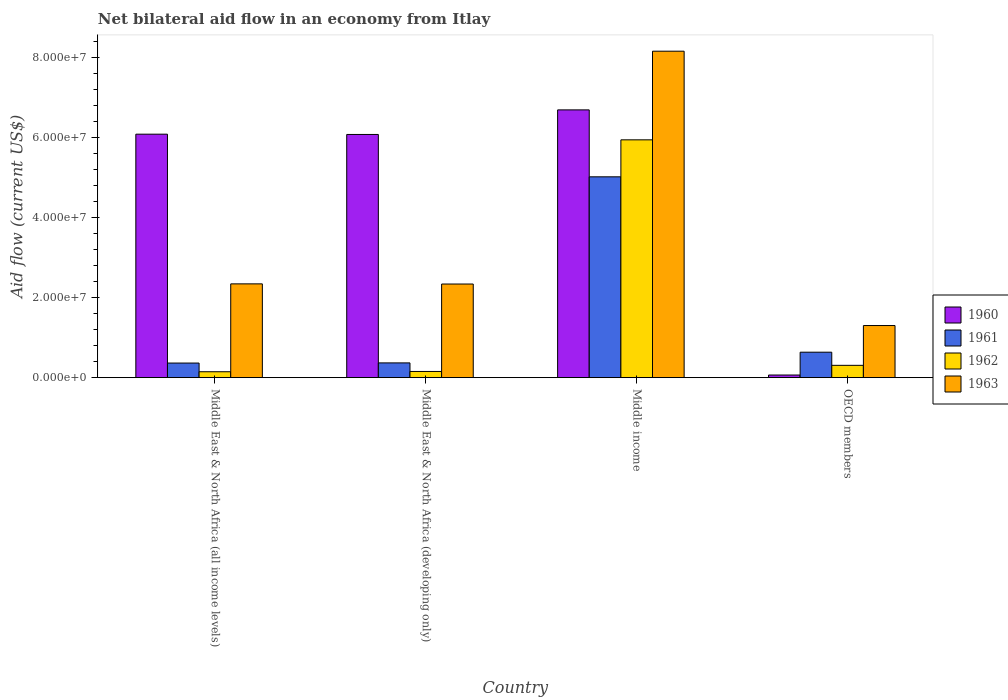How many different coloured bars are there?
Ensure brevity in your answer.  4. Are the number of bars per tick equal to the number of legend labels?
Give a very brief answer. Yes. How many bars are there on the 2nd tick from the left?
Give a very brief answer. 4. How many bars are there on the 2nd tick from the right?
Provide a short and direct response. 4. What is the label of the 1st group of bars from the left?
Give a very brief answer. Middle East & North Africa (all income levels). In how many cases, is the number of bars for a given country not equal to the number of legend labels?
Your answer should be compact. 0. What is the net bilateral aid flow in 1961 in Middle income?
Your response must be concise. 5.02e+07. Across all countries, what is the maximum net bilateral aid flow in 1960?
Your response must be concise. 6.69e+07. Across all countries, what is the minimum net bilateral aid flow in 1962?
Offer a very short reply. 1.48e+06. In which country was the net bilateral aid flow in 1961 maximum?
Offer a terse response. Middle income. In which country was the net bilateral aid flow in 1960 minimum?
Make the answer very short. OECD members. What is the total net bilateral aid flow in 1963 in the graph?
Give a very brief answer. 1.41e+08. What is the difference between the net bilateral aid flow in 1960 in Middle income and that in OECD members?
Make the answer very short. 6.62e+07. What is the difference between the net bilateral aid flow in 1962 in OECD members and the net bilateral aid flow in 1963 in Middle East & North Africa (all income levels)?
Your answer should be very brief. -2.04e+07. What is the average net bilateral aid flow in 1960 per country?
Your answer should be compact. 4.73e+07. What is the difference between the net bilateral aid flow of/in 1963 and net bilateral aid flow of/in 1962 in Middle income?
Ensure brevity in your answer.  2.21e+07. What is the ratio of the net bilateral aid flow in 1963 in Middle East & North Africa (all income levels) to that in OECD members?
Ensure brevity in your answer.  1.8. Is the difference between the net bilateral aid flow in 1963 in Middle East & North Africa (all income levels) and OECD members greater than the difference between the net bilateral aid flow in 1962 in Middle East & North Africa (all income levels) and OECD members?
Offer a terse response. Yes. What is the difference between the highest and the second highest net bilateral aid flow in 1963?
Make the answer very short. 5.82e+07. What is the difference between the highest and the lowest net bilateral aid flow in 1961?
Your response must be concise. 4.65e+07. Is it the case that in every country, the sum of the net bilateral aid flow in 1961 and net bilateral aid flow in 1963 is greater than the sum of net bilateral aid flow in 1962 and net bilateral aid flow in 1960?
Provide a short and direct response. Yes. What does the 2nd bar from the right in Middle East & North Africa (all income levels) represents?
Provide a succinct answer. 1962. Is it the case that in every country, the sum of the net bilateral aid flow in 1962 and net bilateral aid flow in 1960 is greater than the net bilateral aid flow in 1961?
Provide a succinct answer. No. How many bars are there?
Your answer should be very brief. 16. How many countries are there in the graph?
Ensure brevity in your answer.  4. What is the difference between two consecutive major ticks on the Y-axis?
Provide a succinct answer. 2.00e+07. Are the values on the major ticks of Y-axis written in scientific E-notation?
Your answer should be compact. Yes. Where does the legend appear in the graph?
Make the answer very short. Center right. What is the title of the graph?
Your answer should be very brief. Net bilateral aid flow in an economy from Itlay. What is the Aid flow (current US$) of 1960 in Middle East & North Africa (all income levels)?
Your answer should be very brief. 6.08e+07. What is the Aid flow (current US$) of 1961 in Middle East & North Africa (all income levels)?
Ensure brevity in your answer.  3.65e+06. What is the Aid flow (current US$) in 1962 in Middle East & North Africa (all income levels)?
Ensure brevity in your answer.  1.48e+06. What is the Aid flow (current US$) in 1963 in Middle East & North Africa (all income levels)?
Your response must be concise. 2.34e+07. What is the Aid flow (current US$) of 1960 in Middle East & North Africa (developing only)?
Make the answer very short. 6.08e+07. What is the Aid flow (current US$) of 1961 in Middle East & North Africa (developing only)?
Ensure brevity in your answer.  3.69e+06. What is the Aid flow (current US$) in 1962 in Middle East & North Africa (developing only)?
Offer a very short reply. 1.55e+06. What is the Aid flow (current US$) of 1963 in Middle East & North Africa (developing only)?
Make the answer very short. 2.34e+07. What is the Aid flow (current US$) in 1960 in Middle income?
Provide a short and direct response. 6.69e+07. What is the Aid flow (current US$) of 1961 in Middle income?
Your response must be concise. 5.02e+07. What is the Aid flow (current US$) in 1962 in Middle income?
Keep it short and to the point. 5.94e+07. What is the Aid flow (current US$) of 1963 in Middle income?
Make the answer very short. 8.16e+07. What is the Aid flow (current US$) of 1960 in OECD members?
Your answer should be compact. 6.60e+05. What is the Aid flow (current US$) in 1961 in OECD members?
Offer a very short reply. 6.36e+06. What is the Aid flow (current US$) of 1962 in OECD members?
Offer a terse response. 3.08e+06. What is the Aid flow (current US$) of 1963 in OECD members?
Offer a terse response. 1.30e+07. Across all countries, what is the maximum Aid flow (current US$) of 1960?
Your response must be concise. 6.69e+07. Across all countries, what is the maximum Aid flow (current US$) of 1961?
Keep it short and to the point. 5.02e+07. Across all countries, what is the maximum Aid flow (current US$) of 1962?
Keep it short and to the point. 5.94e+07. Across all countries, what is the maximum Aid flow (current US$) of 1963?
Keep it short and to the point. 8.16e+07. Across all countries, what is the minimum Aid flow (current US$) in 1961?
Offer a terse response. 3.65e+06. Across all countries, what is the minimum Aid flow (current US$) in 1962?
Make the answer very short. 1.48e+06. Across all countries, what is the minimum Aid flow (current US$) of 1963?
Your answer should be compact. 1.30e+07. What is the total Aid flow (current US$) in 1960 in the graph?
Your answer should be very brief. 1.89e+08. What is the total Aid flow (current US$) of 1961 in the graph?
Your answer should be very brief. 6.39e+07. What is the total Aid flow (current US$) of 1962 in the graph?
Your response must be concise. 6.55e+07. What is the total Aid flow (current US$) in 1963 in the graph?
Your answer should be very brief. 1.41e+08. What is the difference between the Aid flow (current US$) in 1962 in Middle East & North Africa (all income levels) and that in Middle East & North Africa (developing only)?
Your answer should be compact. -7.00e+04. What is the difference between the Aid flow (current US$) in 1963 in Middle East & North Africa (all income levels) and that in Middle East & North Africa (developing only)?
Offer a very short reply. 4.00e+04. What is the difference between the Aid flow (current US$) of 1960 in Middle East & North Africa (all income levels) and that in Middle income?
Provide a succinct answer. -6.07e+06. What is the difference between the Aid flow (current US$) in 1961 in Middle East & North Africa (all income levels) and that in Middle income?
Your answer should be compact. -4.65e+07. What is the difference between the Aid flow (current US$) of 1962 in Middle East & North Africa (all income levels) and that in Middle income?
Your response must be concise. -5.79e+07. What is the difference between the Aid flow (current US$) in 1963 in Middle East & North Africa (all income levels) and that in Middle income?
Ensure brevity in your answer.  -5.81e+07. What is the difference between the Aid flow (current US$) in 1960 in Middle East & North Africa (all income levels) and that in OECD members?
Provide a succinct answer. 6.02e+07. What is the difference between the Aid flow (current US$) of 1961 in Middle East & North Africa (all income levels) and that in OECD members?
Provide a succinct answer. -2.71e+06. What is the difference between the Aid flow (current US$) of 1962 in Middle East & North Africa (all income levels) and that in OECD members?
Your answer should be compact. -1.60e+06. What is the difference between the Aid flow (current US$) in 1963 in Middle East & North Africa (all income levels) and that in OECD members?
Your answer should be compact. 1.04e+07. What is the difference between the Aid flow (current US$) in 1960 in Middle East & North Africa (developing only) and that in Middle income?
Your response must be concise. -6.14e+06. What is the difference between the Aid flow (current US$) in 1961 in Middle East & North Africa (developing only) and that in Middle income?
Ensure brevity in your answer.  -4.65e+07. What is the difference between the Aid flow (current US$) of 1962 in Middle East & North Africa (developing only) and that in Middle income?
Ensure brevity in your answer.  -5.79e+07. What is the difference between the Aid flow (current US$) of 1963 in Middle East & North Africa (developing only) and that in Middle income?
Provide a succinct answer. -5.82e+07. What is the difference between the Aid flow (current US$) in 1960 in Middle East & North Africa (developing only) and that in OECD members?
Offer a very short reply. 6.01e+07. What is the difference between the Aid flow (current US$) in 1961 in Middle East & North Africa (developing only) and that in OECD members?
Your answer should be compact. -2.67e+06. What is the difference between the Aid flow (current US$) in 1962 in Middle East & North Africa (developing only) and that in OECD members?
Offer a very short reply. -1.53e+06. What is the difference between the Aid flow (current US$) of 1963 in Middle East & North Africa (developing only) and that in OECD members?
Your answer should be very brief. 1.04e+07. What is the difference between the Aid flow (current US$) in 1960 in Middle income and that in OECD members?
Keep it short and to the point. 6.62e+07. What is the difference between the Aid flow (current US$) in 1961 in Middle income and that in OECD members?
Ensure brevity in your answer.  4.38e+07. What is the difference between the Aid flow (current US$) in 1962 in Middle income and that in OECD members?
Your response must be concise. 5.63e+07. What is the difference between the Aid flow (current US$) of 1963 in Middle income and that in OECD members?
Keep it short and to the point. 6.85e+07. What is the difference between the Aid flow (current US$) of 1960 in Middle East & North Africa (all income levels) and the Aid flow (current US$) of 1961 in Middle East & North Africa (developing only)?
Offer a very short reply. 5.71e+07. What is the difference between the Aid flow (current US$) in 1960 in Middle East & North Africa (all income levels) and the Aid flow (current US$) in 1962 in Middle East & North Africa (developing only)?
Make the answer very short. 5.93e+07. What is the difference between the Aid flow (current US$) of 1960 in Middle East & North Africa (all income levels) and the Aid flow (current US$) of 1963 in Middle East & North Africa (developing only)?
Provide a short and direct response. 3.74e+07. What is the difference between the Aid flow (current US$) of 1961 in Middle East & North Africa (all income levels) and the Aid flow (current US$) of 1962 in Middle East & North Africa (developing only)?
Give a very brief answer. 2.10e+06. What is the difference between the Aid flow (current US$) in 1961 in Middle East & North Africa (all income levels) and the Aid flow (current US$) in 1963 in Middle East & North Africa (developing only)?
Give a very brief answer. -1.97e+07. What is the difference between the Aid flow (current US$) in 1962 in Middle East & North Africa (all income levels) and the Aid flow (current US$) in 1963 in Middle East & North Africa (developing only)?
Give a very brief answer. -2.19e+07. What is the difference between the Aid flow (current US$) in 1960 in Middle East & North Africa (all income levels) and the Aid flow (current US$) in 1961 in Middle income?
Offer a very short reply. 1.06e+07. What is the difference between the Aid flow (current US$) in 1960 in Middle East & North Africa (all income levels) and the Aid flow (current US$) in 1962 in Middle income?
Provide a short and direct response. 1.41e+06. What is the difference between the Aid flow (current US$) in 1960 in Middle East & North Africa (all income levels) and the Aid flow (current US$) in 1963 in Middle income?
Offer a terse response. -2.07e+07. What is the difference between the Aid flow (current US$) of 1961 in Middle East & North Africa (all income levels) and the Aid flow (current US$) of 1962 in Middle income?
Provide a short and direct response. -5.58e+07. What is the difference between the Aid flow (current US$) in 1961 in Middle East & North Africa (all income levels) and the Aid flow (current US$) in 1963 in Middle income?
Keep it short and to the point. -7.79e+07. What is the difference between the Aid flow (current US$) in 1962 in Middle East & North Africa (all income levels) and the Aid flow (current US$) in 1963 in Middle income?
Ensure brevity in your answer.  -8.01e+07. What is the difference between the Aid flow (current US$) in 1960 in Middle East & North Africa (all income levels) and the Aid flow (current US$) in 1961 in OECD members?
Your answer should be compact. 5.45e+07. What is the difference between the Aid flow (current US$) in 1960 in Middle East & North Africa (all income levels) and the Aid flow (current US$) in 1962 in OECD members?
Provide a succinct answer. 5.77e+07. What is the difference between the Aid flow (current US$) of 1960 in Middle East & North Africa (all income levels) and the Aid flow (current US$) of 1963 in OECD members?
Keep it short and to the point. 4.78e+07. What is the difference between the Aid flow (current US$) in 1961 in Middle East & North Africa (all income levels) and the Aid flow (current US$) in 1962 in OECD members?
Give a very brief answer. 5.70e+05. What is the difference between the Aid flow (current US$) in 1961 in Middle East & North Africa (all income levels) and the Aid flow (current US$) in 1963 in OECD members?
Offer a very short reply. -9.37e+06. What is the difference between the Aid flow (current US$) in 1962 in Middle East & North Africa (all income levels) and the Aid flow (current US$) in 1963 in OECD members?
Offer a terse response. -1.15e+07. What is the difference between the Aid flow (current US$) in 1960 in Middle East & North Africa (developing only) and the Aid flow (current US$) in 1961 in Middle income?
Offer a terse response. 1.06e+07. What is the difference between the Aid flow (current US$) in 1960 in Middle East & North Africa (developing only) and the Aid flow (current US$) in 1962 in Middle income?
Keep it short and to the point. 1.34e+06. What is the difference between the Aid flow (current US$) in 1960 in Middle East & North Africa (developing only) and the Aid flow (current US$) in 1963 in Middle income?
Your response must be concise. -2.08e+07. What is the difference between the Aid flow (current US$) in 1961 in Middle East & North Africa (developing only) and the Aid flow (current US$) in 1962 in Middle income?
Your answer should be compact. -5.57e+07. What is the difference between the Aid flow (current US$) of 1961 in Middle East & North Africa (developing only) and the Aid flow (current US$) of 1963 in Middle income?
Your answer should be very brief. -7.79e+07. What is the difference between the Aid flow (current US$) of 1962 in Middle East & North Africa (developing only) and the Aid flow (current US$) of 1963 in Middle income?
Your answer should be very brief. -8.00e+07. What is the difference between the Aid flow (current US$) in 1960 in Middle East & North Africa (developing only) and the Aid flow (current US$) in 1961 in OECD members?
Your response must be concise. 5.44e+07. What is the difference between the Aid flow (current US$) of 1960 in Middle East & North Africa (developing only) and the Aid flow (current US$) of 1962 in OECD members?
Ensure brevity in your answer.  5.77e+07. What is the difference between the Aid flow (current US$) in 1960 in Middle East & North Africa (developing only) and the Aid flow (current US$) in 1963 in OECD members?
Your answer should be compact. 4.77e+07. What is the difference between the Aid flow (current US$) in 1961 in Middle East & North Africa (developing only) and the Aid flow (current US$) in 1963 in OECD members?
Your answer should be very brief. -9.33e+06. What is the difference between the Aid flow (current US$) in 1962 in Middle East & North Africa (developing only) and the Aid flow (current US$) in 1963 in OECD members?
Offer a very short reply. -1.15e+07. What is the difference between the Aid flow (current US$) in 1960 in Middle income and the Aid flow (current US$) in 1961 in OECD members?
Make the answer very short. 6.05e+07. What is the difference between the Aid flow (current US$) of 1960 in Middle income and the Aid flow (current US$) of 1962 in OECD members?
Offer a very short reply. 6.38e+07. What is the difference between the Aid flow (current US$) in 1960 in Middle income and the Aid flow (current US$) in 1963 in OECD members?
Give a very brief answer. 5.39e+07. What is the difference between the Aid flow (current US$) in 1961 in Middle income and the Aid flow (current US$) in 1962 in OECD members?
Ensure brevity in your answer.  4.71e+07. What is the difference between the Aid flow (current US$) in 1961 in Middle income and the Aid flow (current US$) in 1963 in OECD members?
Your answer should be very brief. 3.72e+07. What is the difference between the Aid flow (current US$) in 1962 in Middle income and the Aid flow (current US$) in 1963 in OECD members?
Keep it short and to the point. 4.64e+07. What is the average Aid flow (current US$) in 1960 per country?
Ensure brevity in your answer.  4.73e+07. What is the average Aid flow (current US$) in 1961 per country?
Keep it short and to the point. 1.60e+07. What is the average Aid flow (current US$) of 1962 per country?
Give a very brief answer. 1.64e+07. What is the average Aid flow (current US$) in 1963 per country?
Provide a succinct answer. 3.53e+07. What is the difference between the Aid flow (current US$) of 1960 and Aid flow (current US$) of 1961 in Middle East & North Africa (all income levels)?
Offer a terse response. 5.72e+07. What is the difference between the Aid flow (current US$) in 1960 and Aid flow (current US$) in 1962 in Middle East & North Africa (all income levels)?
Keep it short and to the point. 5.93e+07. What is the difference between the Aid flow (current US$) of 1960 and Aid flow (current US$) of 1963 in Middle East & North Africa (all income levels)?
Your answer should be very brief. 3.74e+07. What is the difference between the Aid flow (current US$) of 1961 and Aid flow (current US$) of 1962 in Middle East & North Africa (all income levels)?
Keep it short and to the point. 2.17e+06. What is the difference between the Aid flow (current US$) of 1961 and Aid flow (current US$) of 1963 in Middle East & North Africa (all income levels)?
Provide a succinct answer. -1.98e+07. What is the difference between the Aid flow (current US$) of 1962 and Aid flow (current US$) of 1963 in Middle East & North Africa (all income levels)?
Provide a succinct answer. -2.20e+07. What is the difference between the Aid flow (current US$) in 1960 and Aid flow (current US$) in 1961 in Middle East & North Africa (developing only)?
Your response must be concise. 5.71e+07. What is the difference between the Aid flow (current US$) of 1960 and Aid flow (current US$) of 1962 in Middle East & North Africa (developing only)?
Your response must be concise. 5.92e+07. What is the difference between the Aid flow (current US$) of 1960 and Aid flow (current US$) of 1963 in Middle East & North Africa (developing only)?
Offer a terse response. 3.74e+07. What is the difference between the Aid flow (current US$) in 1961 and Aid flow (current US$) in 1962 in Middle East & North Africa (developing only)?
Keep it short and to the point. 2.14e+06. What is the difference between the Aid flow (current US$) in 1961 and Aid flow (current US$) in 1963 in Middle East & North Africa (developing only)?
Offer a very short reply. -1.97e+07. What is the difference between the Aid flow (current US$) of 1962 and Aid flow (current US$) of 1963 in Middle East & North Africa (developing only)?
Offer a very short reply. -2.18e+07. What is the difference between the Aid flow (current US$) in 1960 and Aid flow (current US$) in 1961 in Middle income?
Provide a short and direct response. 1.67e+07. What is the difference between the Aid flow (current US$) of 1960 and Aid flow (current US$) of 1962 in Middle income?
Your answer should be very brief. 7.48e+06. What is the difference between the Aid flow (current US$) of 1960 and Aid flow (current US$) of 1963 in Middle income?
Offer a terse response. -1.47e+07. What is the difference between the Aid flow (current US$) in 1961 and Aid flow (current US$) in 1962 in Middle income?
Your response must be concise. -9.24e+06. What is the difference between the Aid flow (current US$) in 1961 and Aid flow (current US$) in 1963 in Middle income?
Provide a succinct answer. -3.14e+07. What is the difference between the Aid flow (current US$) of 1962 and Aid flow (current US$) of 1963 in Middle income?
Make the answer very short. -2.21e+07. What is the difference between the Aid flow (current US$) of 1960 and Aid flow (current US$) of 1961 in OECD members?
Ensure brevity in your answer.  -5.70e+06. What is the difference between the Aid flow (current US$) in 1960 and Aid flow (current US$) in 1962 in OECD members?
Make the answer very short. -2.42e+06. What is the difference between the Aid flow (current US$) of 1960 and Aid flow (current US$) of 1963 in OECD members?
Make the answer very short. -1.24e+07. What is the difference between the Aid flow (current US$) of 1961 and Aid flow (current US$) of 1962 in OECD members?
Your answer should be very brief. 3.28e+06. What is the difference between the Aid flow (current US$) in 1961 and Aid flow (current US$) in 1963 in OECD members?
Offer a terse response. -6.66e+06. What is the difference between the Aid flow (current US$) in 1962 and Aid flow (current US$) in 1963 in OECD members?
Make the answer very short. -9.94e+06. What is the ratio of the Aid flow (current US$) in 1960 in Middle East & North Africa (all income levels) to that in Middle East & North Africa (developing only)?
Your answer should be very brief. 1. What is the ratio of the Aid flow (current US$) in 1962 in Middle East & North Africa (all income levels) to that in Middle East & North Africa (developing only)?
Offer a very short reply. 0.95. What is the ratio of the Aid flow (current US$) of 1963 in Middle East & North Africa (all income levels) to that in Middle East & North Africa (developing only)?
Your answer should be compact. 1. What is the ratio of the Aid flow (current US$) in 1960 in Middle East & North Africa (all income levels) to that in Middle income?
Offer a very short reply. 0.91. What is the ratio of the Aid flow (current US$) of 1961 in Middle East & North Africa (all income levels) to that in Middle income?
Provide a short and direct response. 0.07. What is the ratio of the Aid flow (current US$) in 1962 in Middle East & North Africa (all income levels) to that in Middle income?
Your answer should be very brief. 0.02. What is the ratio of the Aid flow (current US$) of 1963 in Middle East & North Africa (all income levels) to that in Middle income?
Ensure brevity in your answer.  0.29. What is the ratio of the Aid flow (current US$) in 1960 in Middle East & North Africa (all income levels) to that in OECD members?
Give a very brief answer. 92.15. What is the ratio of the Aid flow (current US$) of 1961 in Middle East & North Africa (all income levels) to that in OECD members?
Offer a very short reply. 0.57. What is the ratio of the Aid flow (current US$) in 1962 in Middle East & North Africa (all income levels) to that in OECD members?
Your answer should be very brief. 0.48. What is the ratio of the Aid flow (current US$) of 1963 in Middle East & North Africa (all income levels) to that in OECD members?
Your response must be concise. 1.8. What is the ratio of the Aid flow (current US$) of 1960 in Middle East & North Africa (developing only) to that in Middle income?
Your answer should be very brief. 0.91. What is the ratio of the Aid flow (current US$) of 1961 in Middle East & North Africa (developing only) to that in Middle income?
Keep it short and to the point. 0.07. What is the ratio of the Aid flow (current US$) in 1962 in Middle East & North Africa (developing only) to that in Middle income?
Your answer should be compact. 0.03. What is the ratio of the Aid flow (current US$) of 1963 in Middle East & North Africa (developing only) to that in Middle income?
Ensure brevity in your answer.  0.29. What is the ratio of the Aid flow (current US$) in 1960 in Middle East & North Africa (developing only) to that in OECD members?
Your answer should be compact. 92.05. What is the ratio of the Aid flow (current US$) of 1961 in Middle East & North Africa (developing only) to that in OECD members?
Your answer should be compact. 0.58. What is the ratio of the Aid flow (current US$) of 1962 in Middle East & North Africa (developing only) to that in OECD members?
Offer a terse response. 0.5. What is the ratio of the Aid flow (current US$) in 1963 in Middle East & North Africa (developing only) to that in OECD members?
Offer a terse response. 1.8. What is the ratio of the Aid flow (current US$) in 1960 in Middle income to that in OECD members?
Your answer should be very brief. 101.35. What is the ratio of the Aid flow (current US$) in 1961 in Middle income to that in OECD members?
Provide a succinct answer. 7.89. What is the ratio of the Aid flow (current US$) in 1962 in Middle income to that in OECD members?
Offer a terse response. 19.29. What is the ratio of the Aid flow (current US$) in 1963 in Middle income to that in OECD members?
Provide a succinct answer. 6.26. What is the difference between the highest and the second highest Aid flow (current US$) of 1960?
Keep it short and to the point. 6.07e+06. What is the difference between the highest and the second highest Aid flow (current US$) of 1961?
Your answer should be compact. 4.38e+07. What is the difference between the highest and the second highest Aid flow (current US$) in 1962?
Make the answer very short. 5.63e+07. What is the difference between the highest and the second highest Aid flow (current US$) of 1963?
Offer a very short reply. 5.81e+07. What is the difference between the highest and the lowest Aid flow (current US$) in 1960?
Your answer should be very brief. 6.62e+07. What is the difference between the highest and the lowest Aid flow (current US$) of 1961?
Offer a terse response. 4.65e+07. What is the difference between the highest and the lowest Aid flow (current US$) in 1962?
Provide a short and direct response. 5.79e+07. What is the difference between the highest and the lowest Aid flow (current US$) in 1963?
Provide a short and direct response. 6.85e+07. 